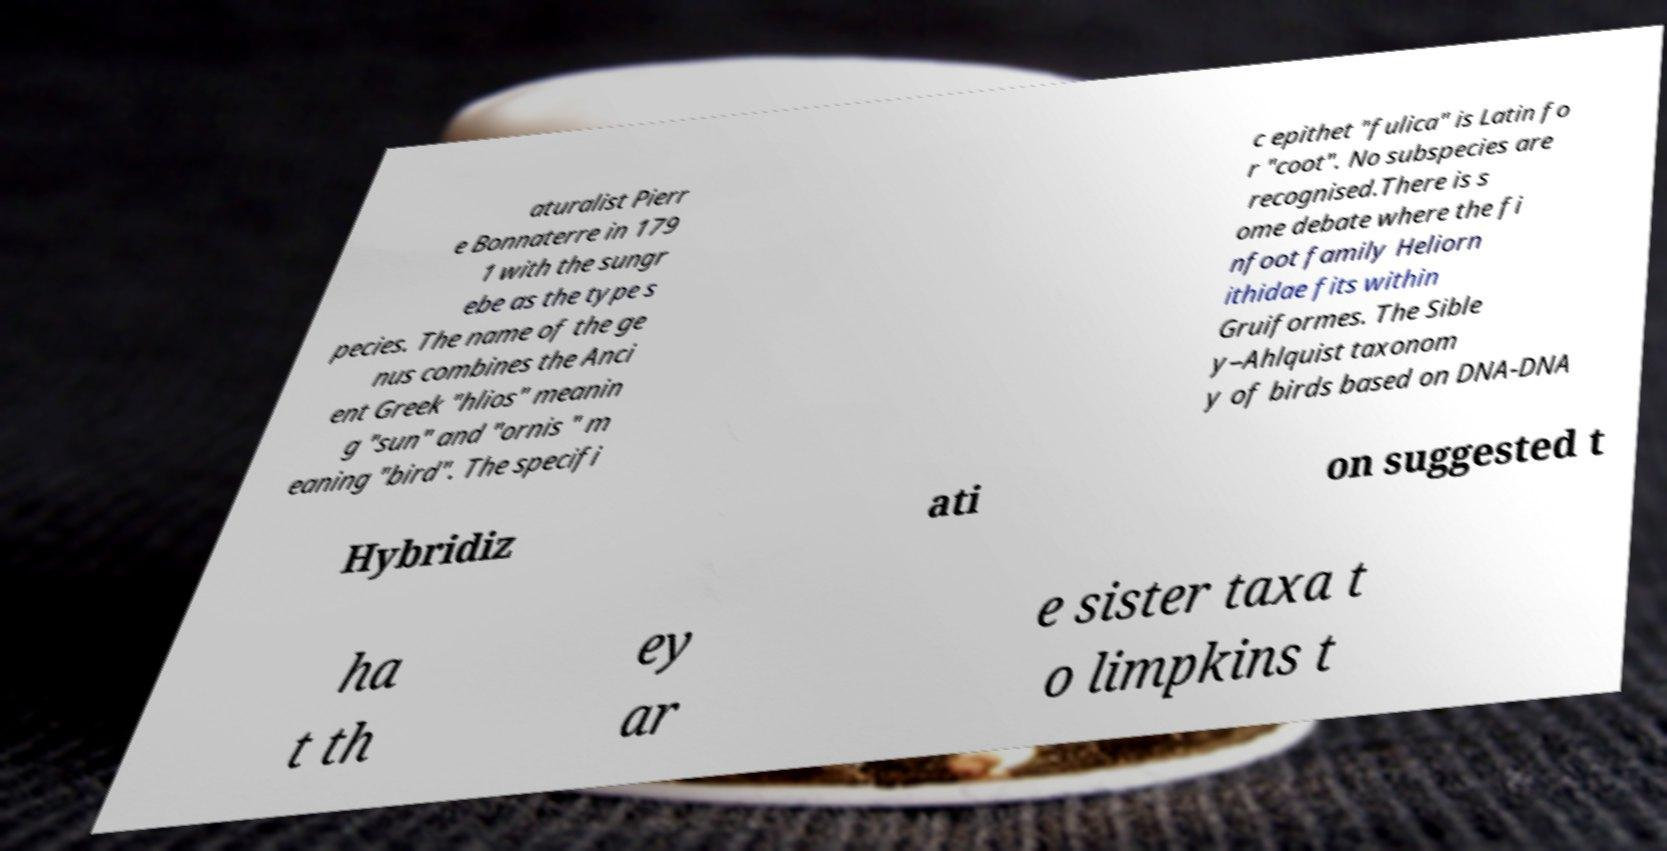Can you accurately transcribe the text from the provided image for me? aturalist Pierr e Bonnaterre in 179 1 with the sungr ebe as the type s pecies. The name of the ge nus combines the Anci ent Greek "hlios" meanin g "sun" and "ornis " m eaning "bird". The specifi c epithet "fulica" is Latin fo r "coot". No subspecies are recognised.There is s ome debate where the fi nfoot family Heliorn ithidae fits within Gruiformes. The Sible y–Ahlquist taxonom y of birds based on DNA-DNA Hybridiz ati on suggested t ha t th ey ar e sister taxa t o limpkins t 